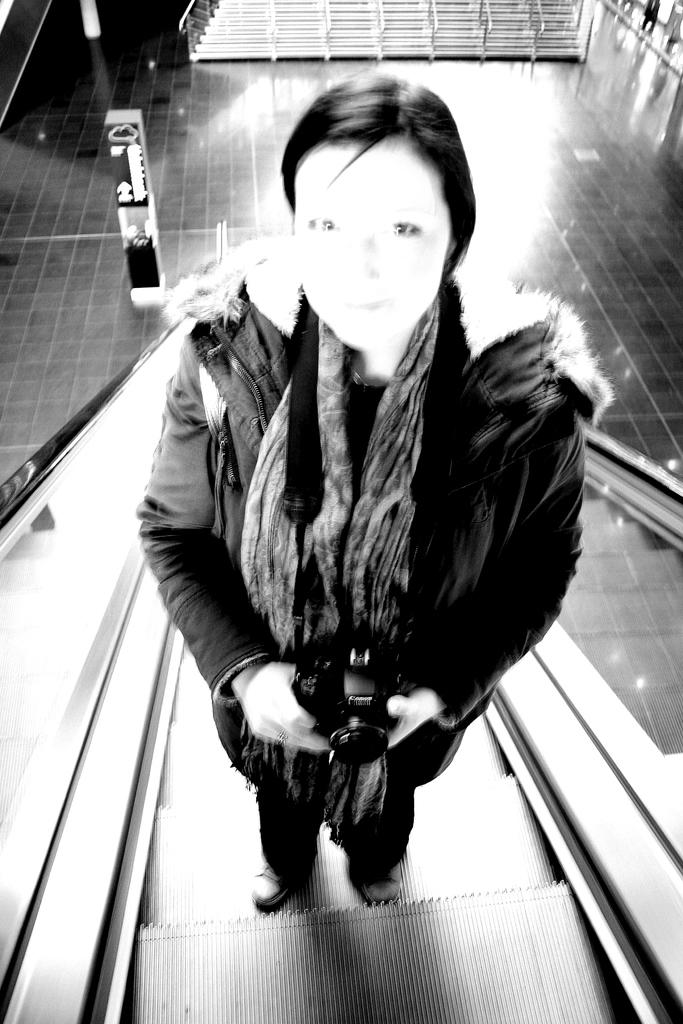What is the color scheme of the image? The image is black and white. Who is present in the image? There is a woman in the image. What is the woman doing in the image? The woman is on an escalator. What is the woman holding in the image? The woman is holding a camera. What can be seen beneath the woman in the image? The image shows a floor. What type of airplane is visible in the image? There is no airplane present in the image; it features a woman on an escalator holding a camera. What shape is the escalator in the image? The escalator's shape cannot be determined from the image, as it is a two-dimensional representation. 